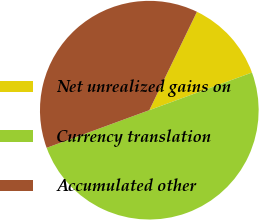Convert chart. <chart><loc_0><loc_0><loc_500><loc_500><pie_chart><fcel>Net unrealized gains on<fcel>Currency translation<fcel>Accumulated other<nl><fcel>12.23%<fcel>50.0%<fcel>37.77%<nl></chart> 